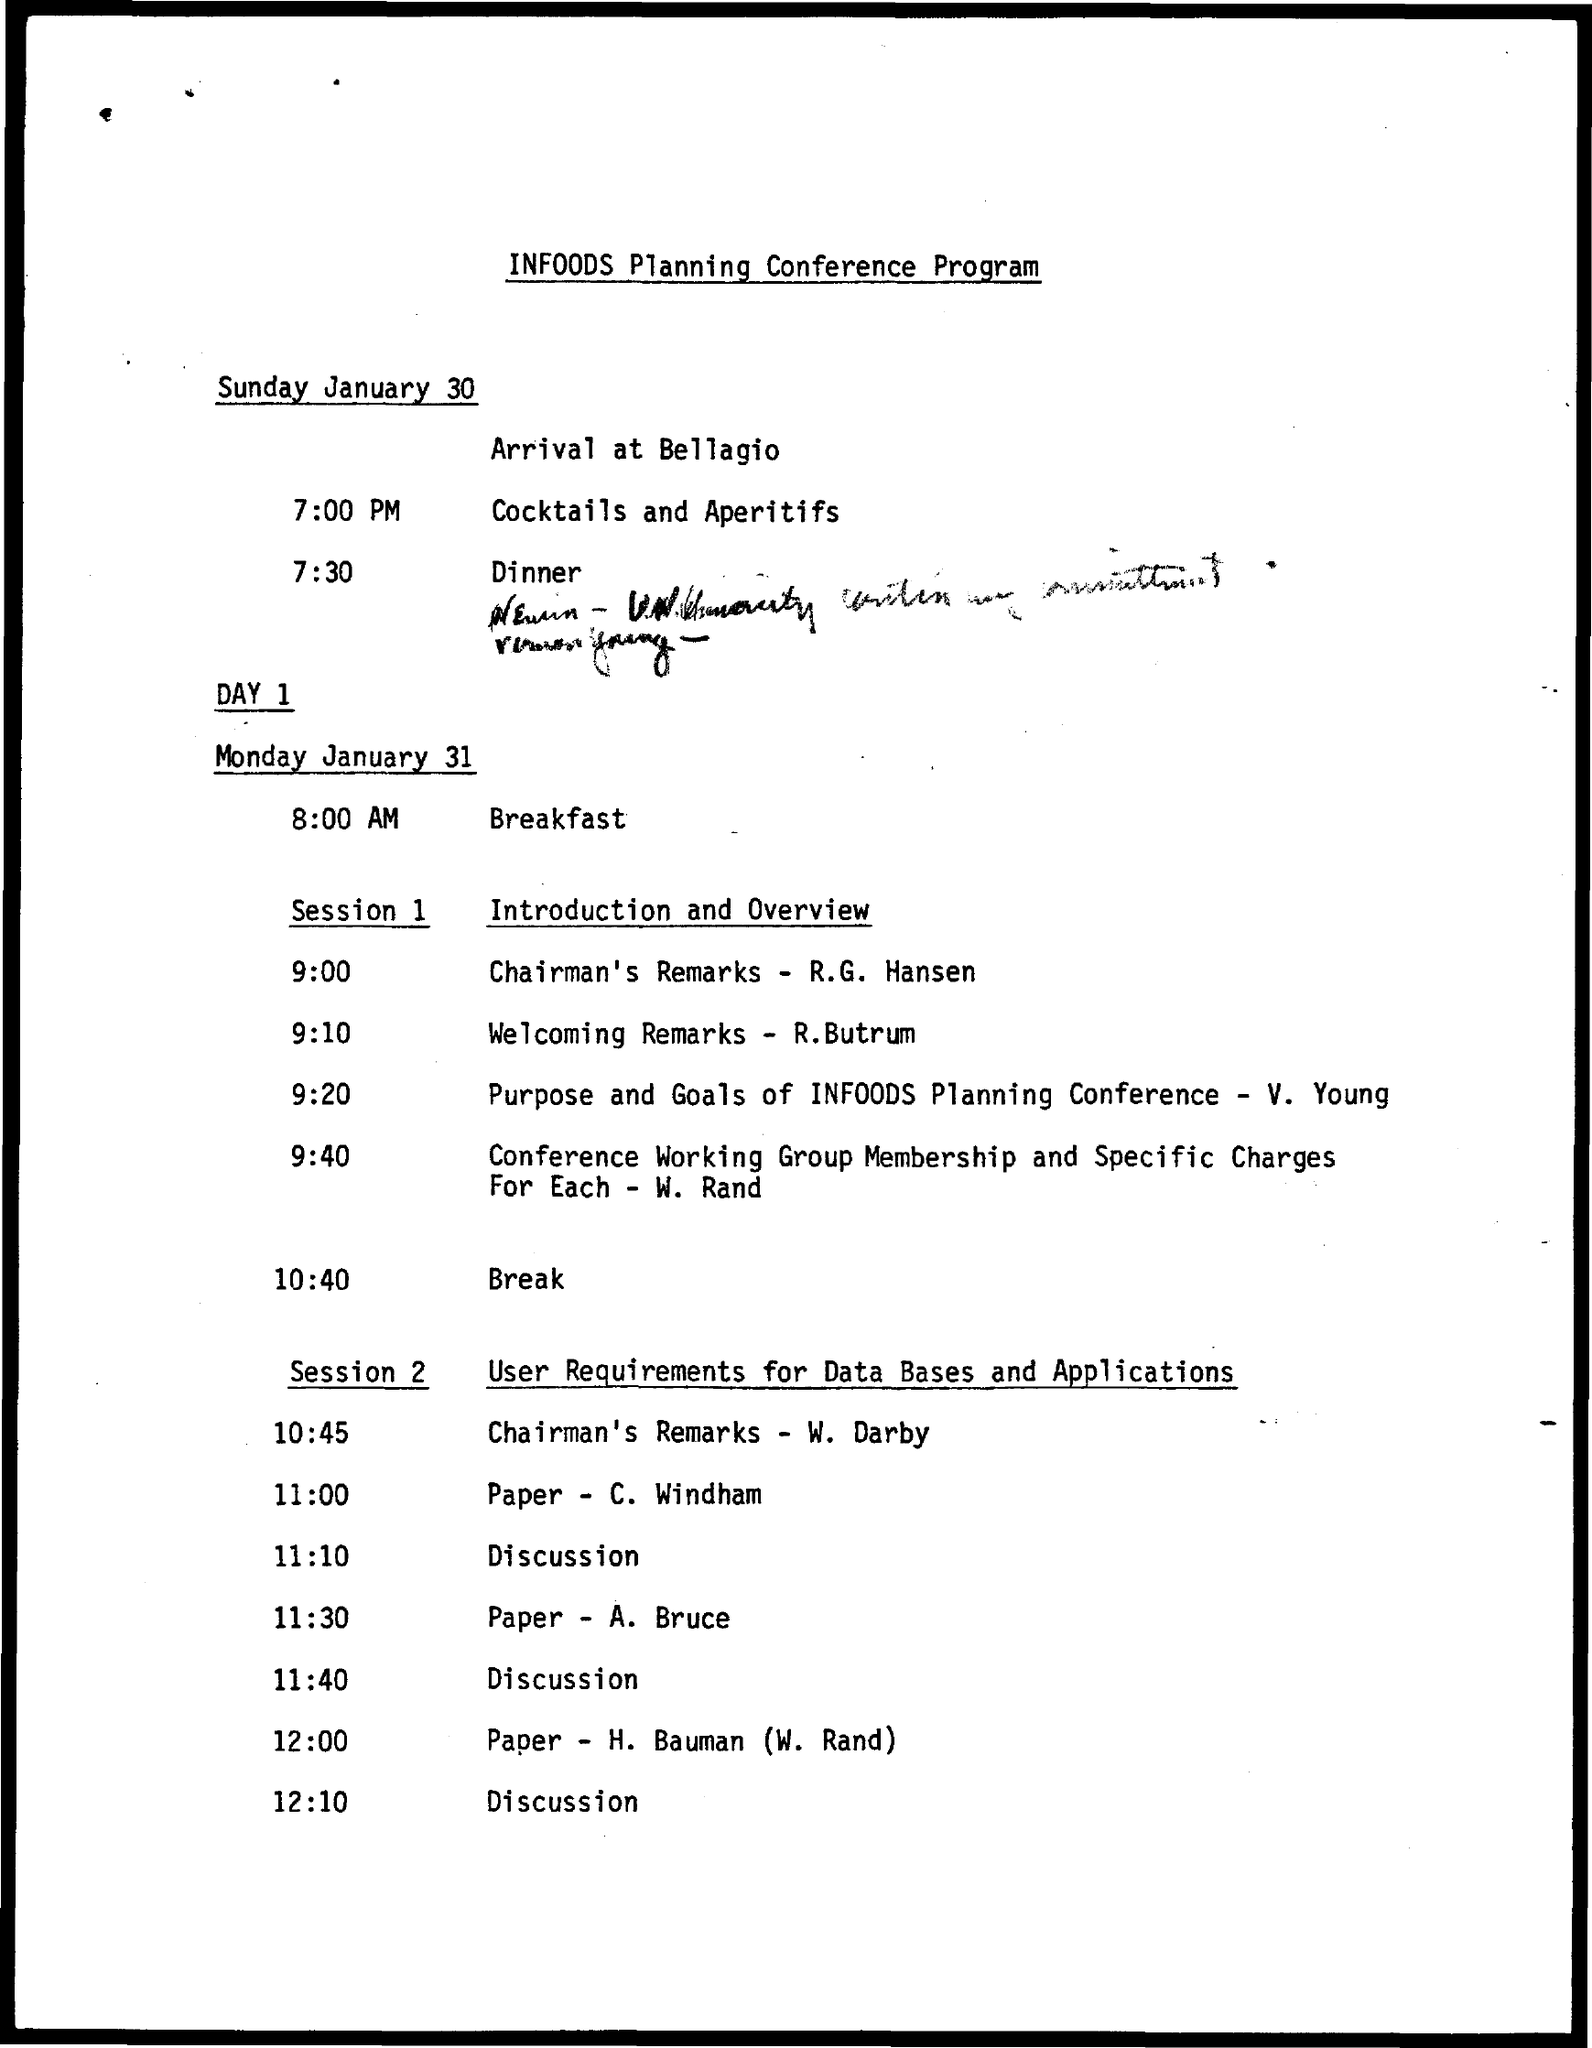Specify some key components in this picture. In session 2, W. Darby will be presenting the Chairman's remarks. R.G. Hansen will be presenting Chairman's remarks in session 1. The paper presentation by A. Bruce is scheduled for 11:30. The welcoming remarks will be presented by R.Butrum at 9:10. The paper presentation by C. Windham is scheduled to take place during session 2 at 11:00. 